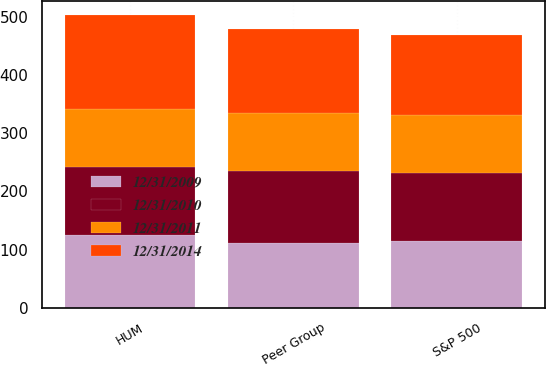Convert chart. <chart><loc_0><loc_0><loc_500><loc_500><stacked_bar_chart><ecel><fcel>HUM<fcel>S&P 500<fcel>Peer Group<nl><fcel>12/31/2011<fcel>100<fcel>100<fcel>100<nl><fcel>12/31/2009<fcel>125<fcel>115<fcel>112<nl><fcel>12/31/2010<fcel>117<fcel>117<fcel>123<nl><fcel>12/31/2014<fcel>160<fcel>136<fcel>144<nl></chart> 